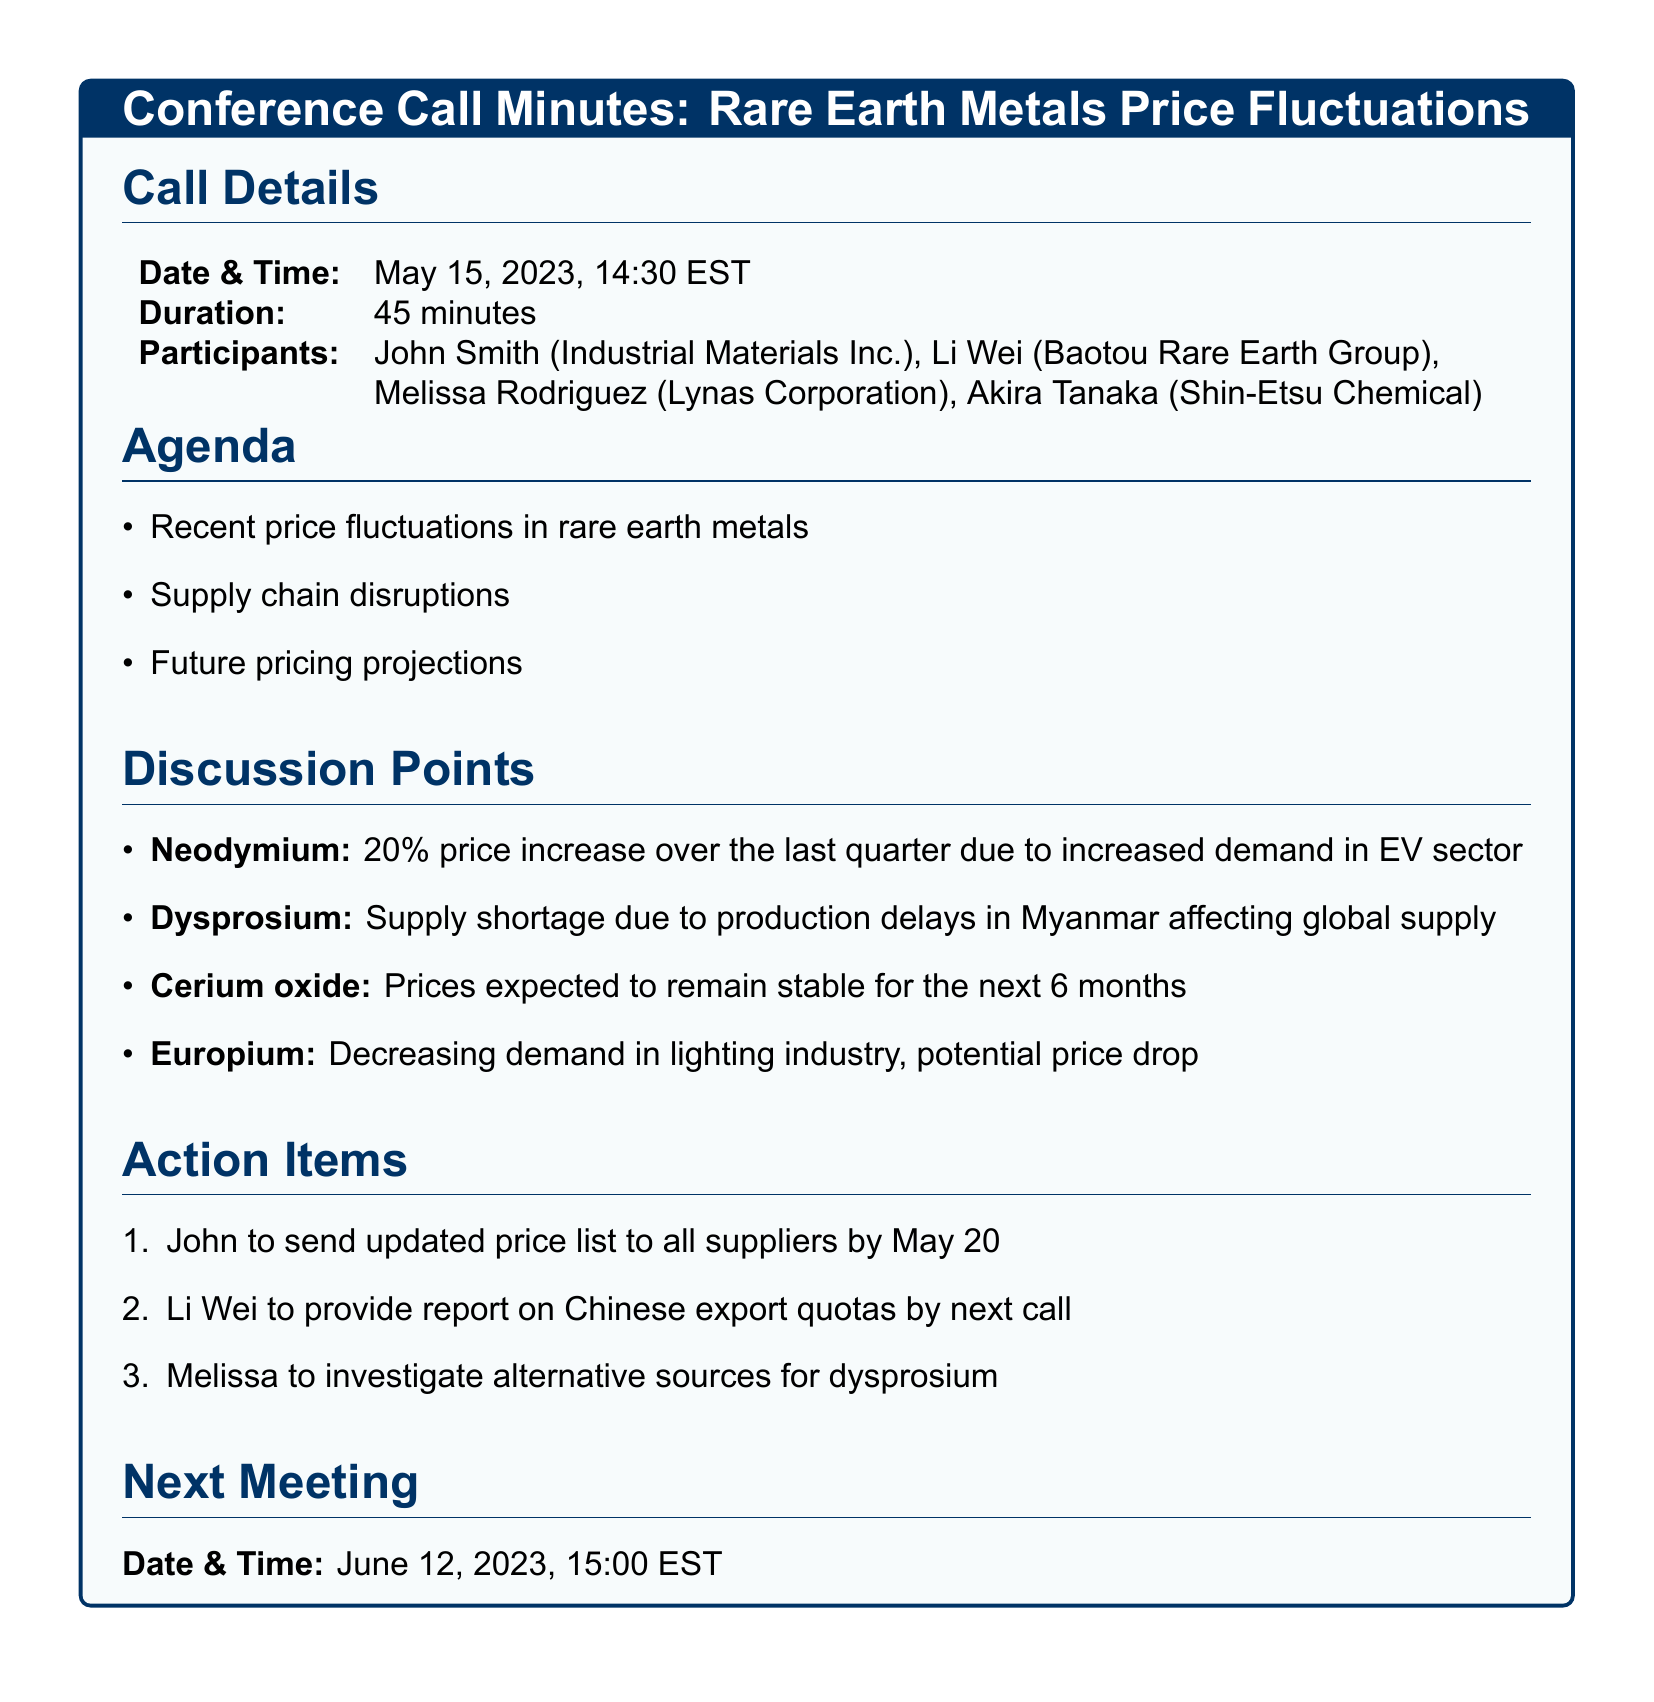What is the date of the call? The date of the call is specified in the call details section.
Answer: May 15, 2023 How long did the call last? The duration of the call is indicated in the call details section.
Answer: 45 minutes Who is the participant from Baotou Rare Earth Group? The participant's name is listed in the call details section.
Answer: Li Wei What was the price increase percentage for Neodymium? The price fluctuation for Neodymium is mentioned in the discussion points.
Answer: 20% What is the expected trend for Cerium oxide prices? The future pricing information for Cerium oxide is provided in the discussion points.
Answer: Stable What specific action is John responsible for? The action items section specifies responsibilities assigned to participants.
Answer: Send updated price list What report will Li Wei provide by the next call? The action items mention the specific report to be provided by Li Wei.
Answer: Chinese export quotas What is the next meeting date? The next meeting date is clearly stated in the document.
Answer: June 12, 2023 